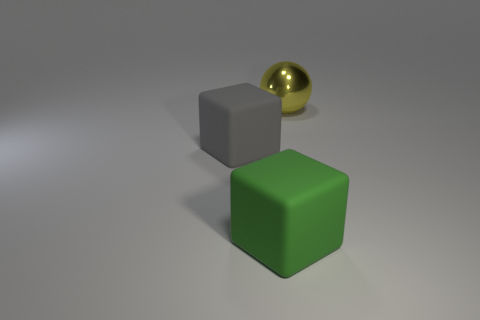What color is the other block that is the same size as the gray cube?
Keep it short and to the point. Green. Do the object on the left side of the green object and the green thing have the same shape?
Offer a terse response. Yes. The big matte block behind the large matte thing to the right of the matte thing behind the big green rubber thing is what color?
Keep it short and to the point. Gray. Are any gray matte cubes visible?
Offer a very short reply. Yes. What number of other objects are the same size as the green rubber thing?
Offer a terse response. 2. What number of things are rubber things or small yellow metallic things?
Keep it short and to the point. 2. Do the large green block and the thing behind the gray cube have the same material?
Provide a short and direct response. No. What shape is the thing that is on the left side of the matte object right of the large gray matte object?
Ensure brevity in your answer.  Cube. The object that is behind the big green cube and in front of the large metal sphere has what shape?
Ensure brevity in your answer.  Cube. How many objects are either big shiny things or matte blocks on the right side of the large gray rubber object?
Give a very brief answer. 2. 